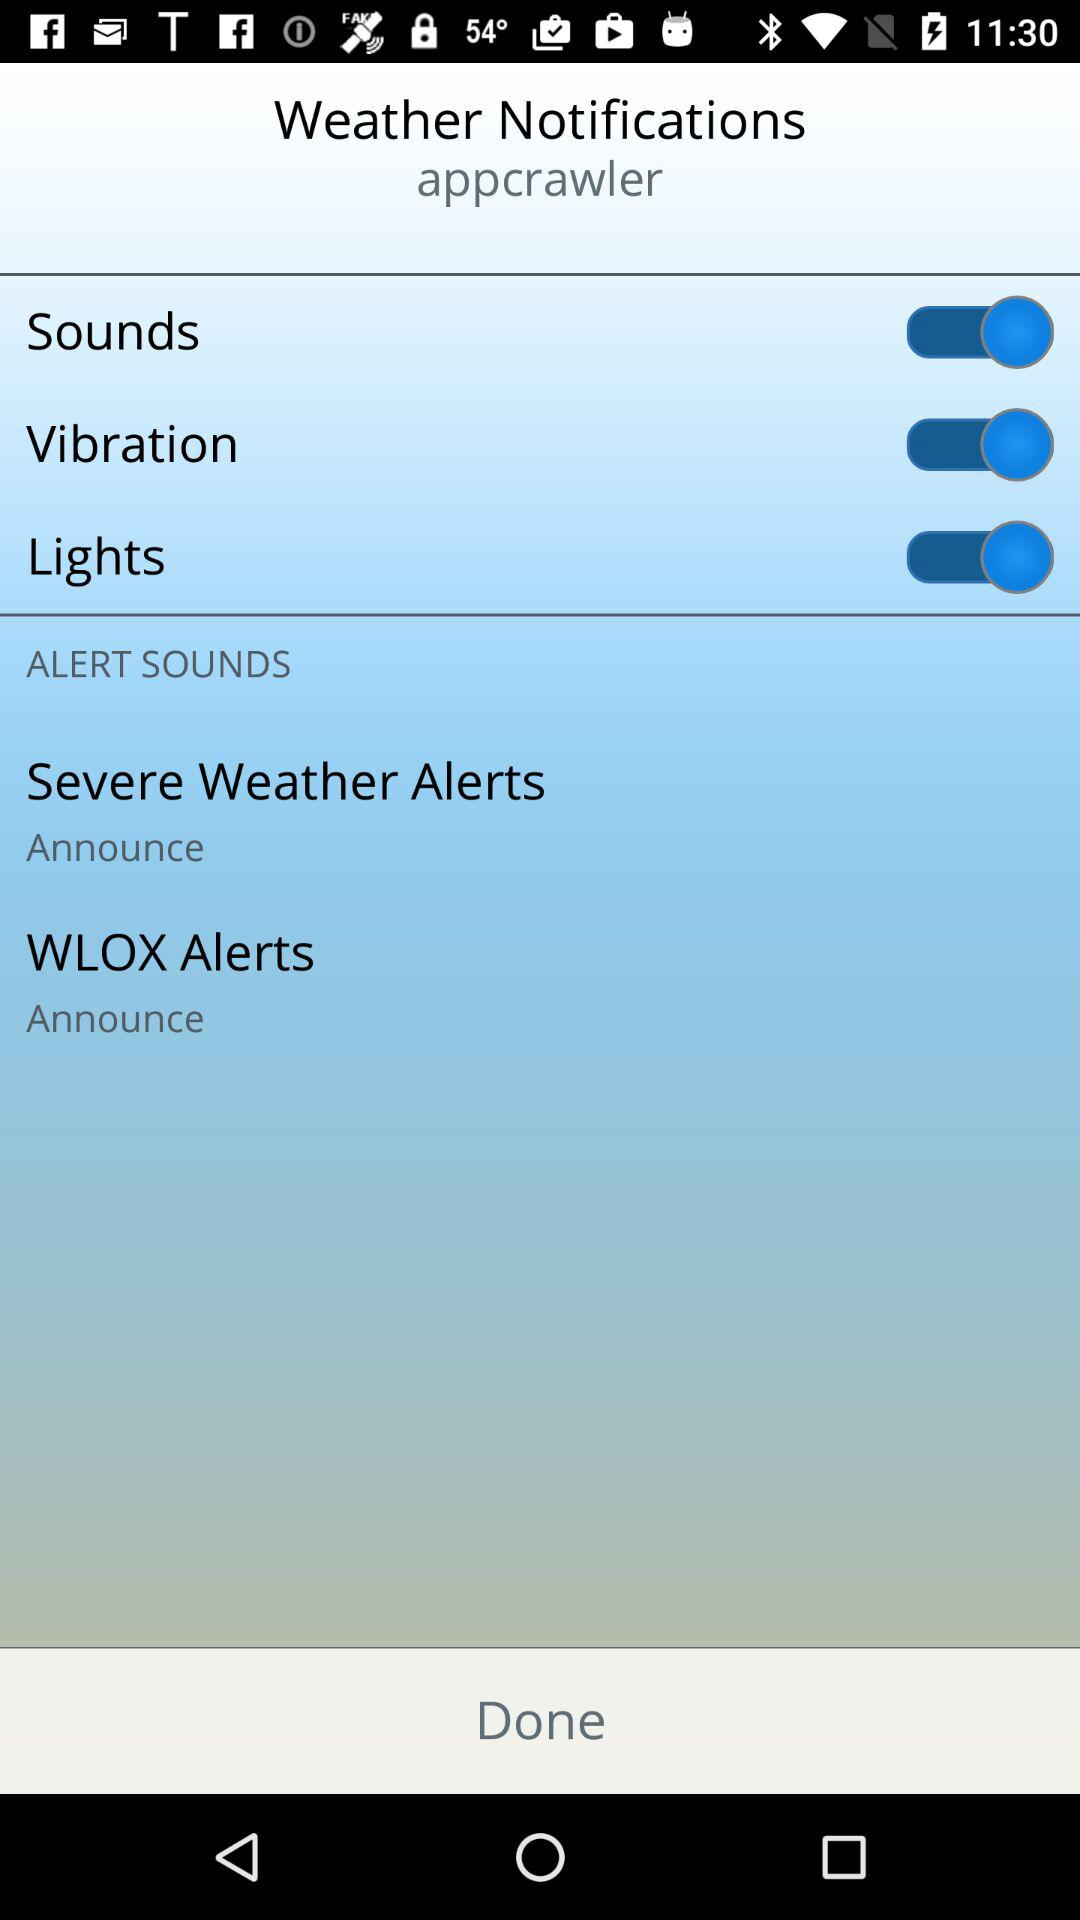What's the status of "Sounds"? The status is "on". 